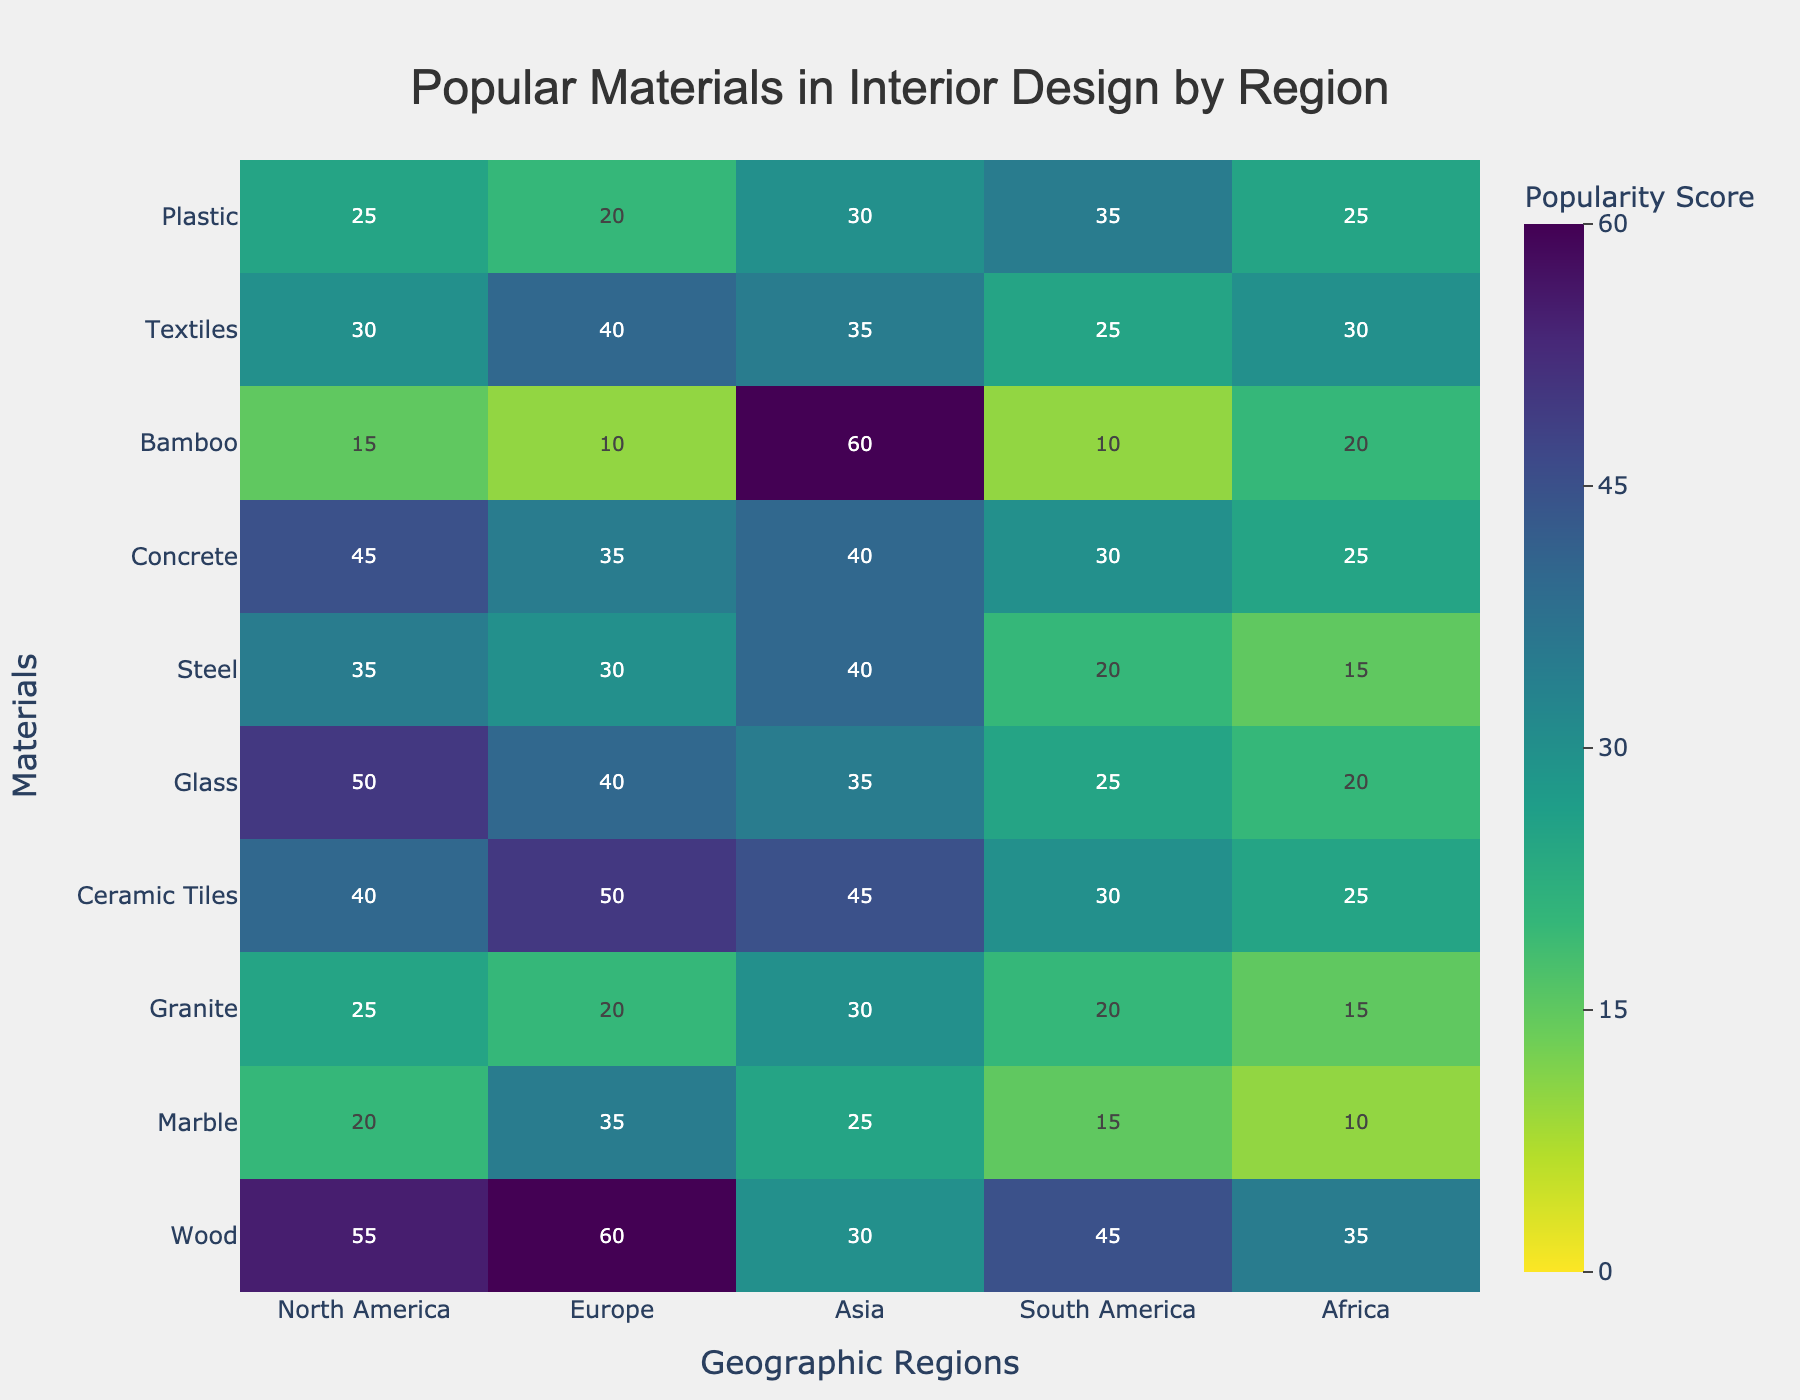What is the material with the highest popularity score in Africa? Check the column for Africa and identify the material with the highest value. Concrete and Ceramic Tiles both have a popularity score of 25, which is the highest in Africa.
Answer: Concrete and Ceramic Tiles Which region has the lowest popularity score for Bamboo? Look at the row for Bamboo and find the lowest value across all regions. Europe has the lowest score of 10.
Answer: Europe What's the total popularity score of Glass across all regions? Sum the values in the row for Glass across all columns. The scores are 50, 40, 35, 25, and 20, giving a total of 170.
Answer: 170 Which material is most popular in South America, and what is its popularity score? Check the column for South America and identify the material with the highest value. Plastic has the highest score of 35.
Answer: Plastic, 35 Compare the popularity of Wood in North America and Europe. Which region prefers it more, and by how much? Find the popularity scores for Wood in North America and Europe, which are 55 and 60, respectively. Subtract the smaller value from the larger. Europe prefers Wood more by 5 points.
Answer: Europe, 5 What is the average popularity score of Marble across all regions? Sum the values for Marble (20, 35, 25, 15, 10), which gives 105, and then divide by the number of regions (5). The average score is 21.
Answer: 21 What is the difference in popularity scores between Granite in North America and Asia? Check the row for Granite and find the values for North America and Asia, which are 25 and 30, respectively. Subtract the smaller value from the larger. The difference is 5.
Answer: 5 Which material has the most consistent popularity scores across all regions (smallest range)? Compute the range (max - min) for each material and find the smallest range. Marble's scores (20, 35, 25, 15, 10) range from 10 to 35, so the range is 25, which is the smallest range.
Answer: Marble Identify the region with the highest popularity score for Ceramic Tiles and provide the value. Check the row for Ceramic Tiles and find the highest score and its corresponding region. Europe has the highest score of 50.
Answer: Europe, 50 On average, which geographic region uses the largest variety of materials (based on average popularity score)? Calculate the average score for each region by summing the values in each column and dividing by the number of materials (10). Then compare these averages. North America's scores sum to 340, giving an average of 34.0, which is the highest.
Answer: North America 